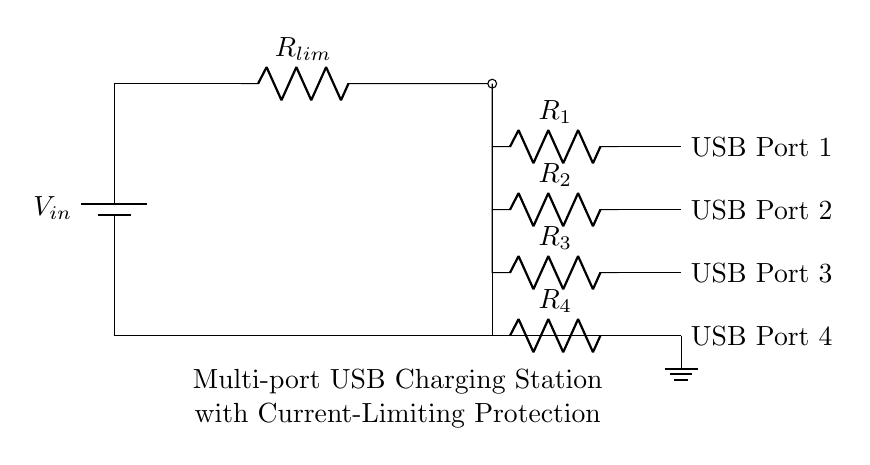What is the input voltage to the circuit? The input voltage is represented as V_in, which is connected to the positive terminal of the battery in the circuit diagram.
Answer: V_in How many USB ports does the charging station have? The circuit diagram shows a total of four connections leading to distinct USB ports, which are labeled as USB Port 1, USB Port 2, USB Port 3, and USB Port 4.
Answer: Four What is the role of R_lim in the circuit? R_lim functions as a current limiting resistor, placed in series to prevent excess current from flowing through the USB ports, thereby protecting the circuit.
Answer: Current limiting What would happen if R_lim has a very low resistance? If R_lim has a very low resistance, the circuit would allow more current to flow, potentially exceeding the safe limits for the USB ports, leading to overheating or damage.
Answer: Excess current flow Which component is responsible for grounding in this circuit? The ground symbol at the bottom of the diagram indicates that the circuit is grounded, providing a reference point for voltages and allowing excess current to safely return to the ground.
Answer: Ground Why is current limiting important in a charging station? Current limiting is crucial to ensure that the charging station operates safely by preventing excessive current flow that could overheat cables or charged devices, maintaining a safe charging environment.
Answer: Prevents overheating 